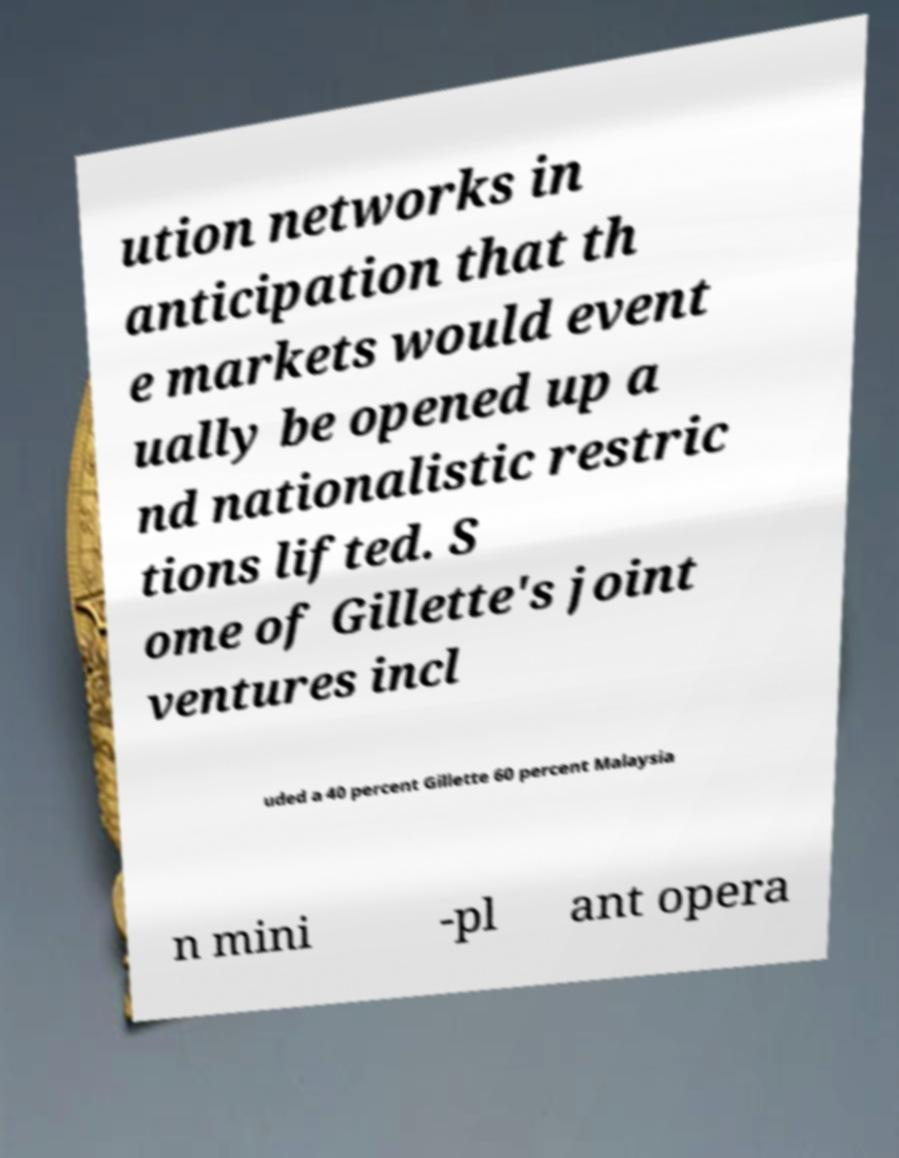For documentation purposes, I need the text within this image transcribed. Could you provide that? ution networks in anticipation that th e markets would event ually be opened up a nd nationalistic restric tions lifted. S ome of Gillette's joint ventures incl uded a 40 percent Gillette 60 percent Malaysia n mini -pl ant opera 